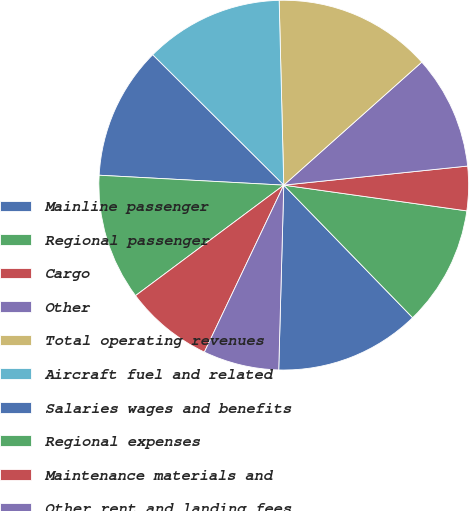Convert chart. <chart><loc_0><loc_0><loc_500><loc_500><pie_chart><fcel>Mainline passenger<fcel>Regional passenger<fcel>Cargo<fcel>Other<fcel>Total operating revenues<fcel>Aircraft fuel and related<fcel>Salaries wages and benefits<fcel>Regional expenses<fcel>Maintenance materials and<fcel>Other rent and landing fees<nl><fcel>12.71%<fcel>10.5%<fcel>3.87%<fcel>9.94%<fcel>13.81%<fcel>12.15%<fcel>11.6%<fcel>11.05%<fcel>7.74%<fcel>6.63%<nl></chart> 